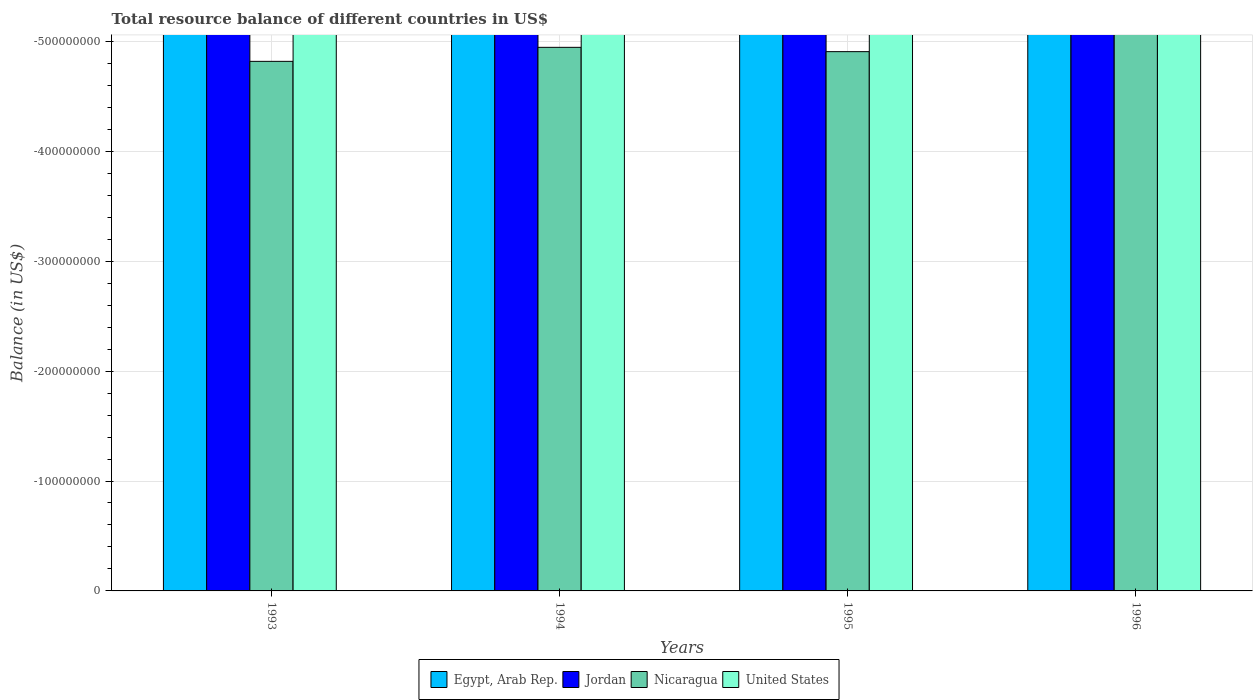How many different coloured bars are there?
Provide a succinct answer. 0. Are the number of bars per tick equal to the number of legend labels?
Offer a very short reply. No. Are the number of bars on each tick of the X-axis equal?
Make the answer very short. Yes. How many bars are there on the 3rd tick from the right?
Offer a very short reply. 0. In how many cases, is the number of bars for a given year not equal to the number of legend labels?
Give a very brief answer. 4. In how many years, is the total resource balance in Nicaragua greater than the average total resource balance in Nicaragua taken over all years?
Ensure brevity in your answer.  0. Is it the case that in every year, the sum of the total resource balance in Jordan and total resource balance in Egypt, Arab Rep. is greater than the sum of total resource balance in Nicaragua and total resource balance in United States?
Your answer should be compact. No. Are all the bars in the graph horizontal?
Keep it short and to the point. No. How many years are there in the graph?
Your answer should be very brief. 4. Does the graph contain any zero values?
Keep it short and to the point. Yes. Does the graph contain grids?
Provide a succinct answer. Yes. Where does the legend appear in the graph?
Provide a short and direct response. Bottom center. How are the legend labels stacked?
Keep it short and to the point. Horizontal. What is the title of the graph?
Offer a terse response. Total resource balance of different countries in US$. What is the label or title of the X-axis?
Keep it short and to the point. Years. What is the label or title of the Y-axis?
Offer a very short reply. Balance (in US$). What is the Balance (in US$) of Egypt, Arab Rep. in 1993?
Your answer should be very brief. 0. What is the Balance (in US$) in United States in 1993?
Your answer should be very brief. 0. What is the Balance (in US$) of Jordan in 1994?
Provide a succinct answer. 0. What is the Balance (in US$) in Egypt, Arab Rep. in 1995?
Give a very brief answer. 0. What is the Balance (in US$) of United States in 1995?
Provide a succinct answer. 0. What is the Balance (in US$) in United States in 1996?
Provide a succinct answer. 0. What is the average Balance (in US$) in Egypt, Arab Rep. per year?
Your answer should be very brief. 0. What is the average Balance (in US$) of United States per year?
Your answer should be compact. 0. 